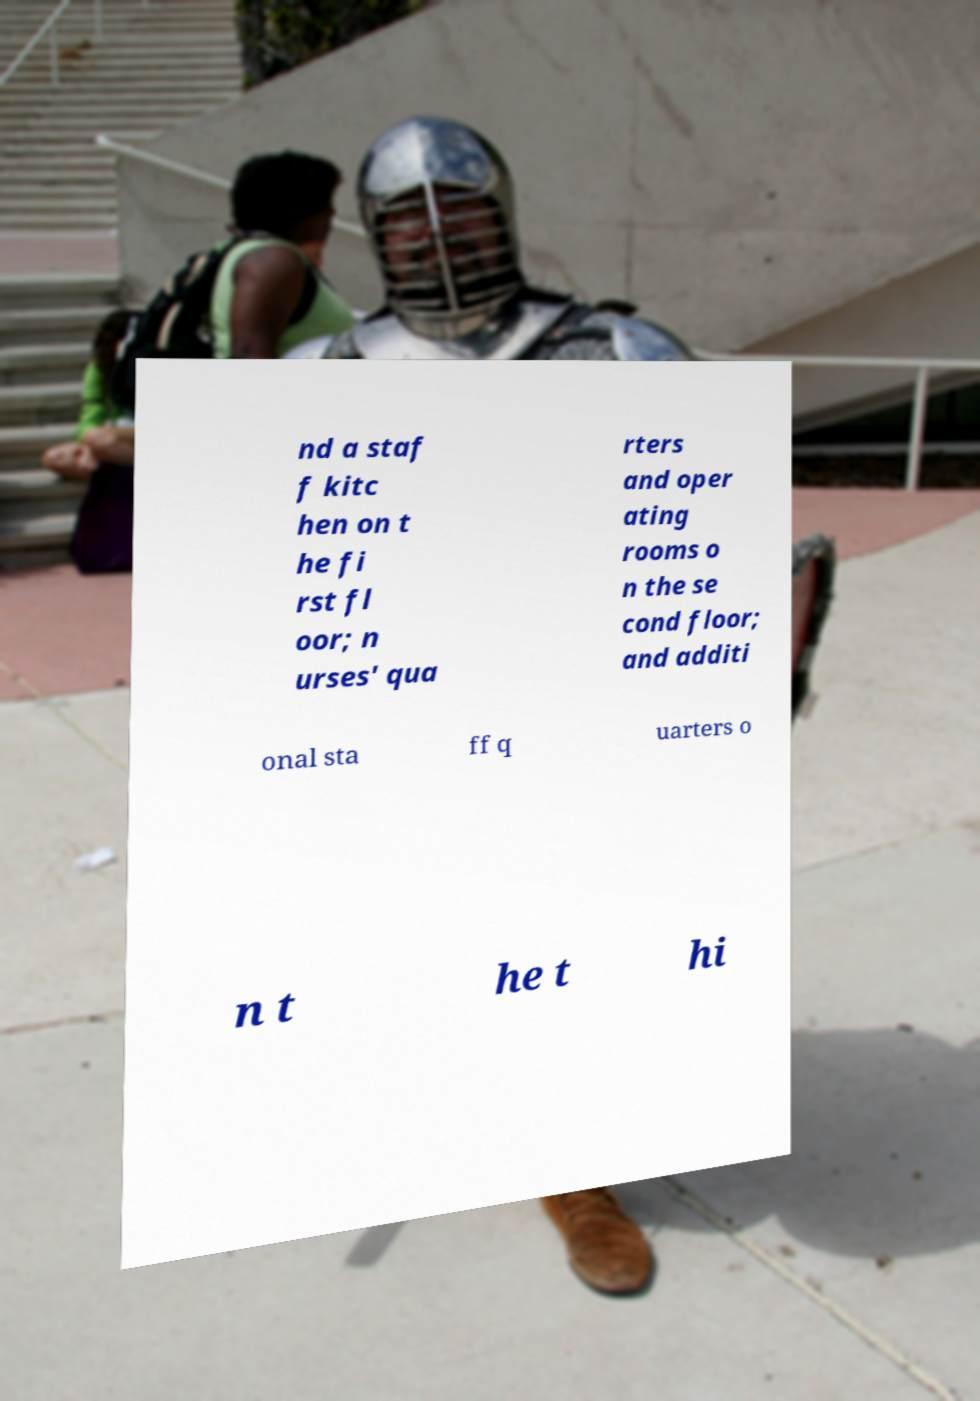There's text embedded in this image that I need extracted. Can you transcribe it verbatim? nd a staf f kitc hen on t he fi rst fl oor; n urses' qua rters and oper ating rooms o n the se cond floor; and additi onal sta ff q uarters o n t he t hi 